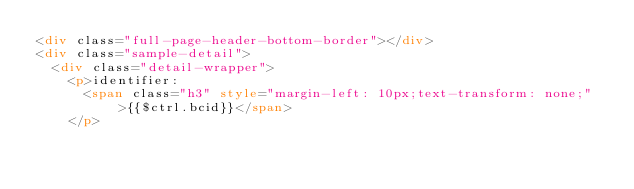Convert code to text. <code><loc_0><loc_0><loc_500><loc_500><_HTML_><div class="full-page-header-bottom-border"></div>
<div class="sample-detail">
  <div class="detail-wrapper">
    <p>identifier:
      <span class="h3" style="margin-left: 10px;text-transform: none;">{{$ctrl.bcid}}</span>
    </p>
</code> 